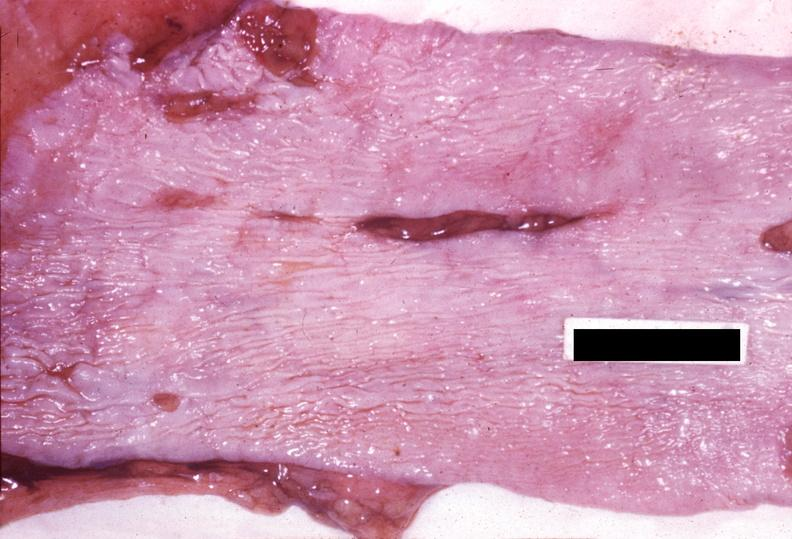s cardiovascular present?
Answer the question using a single word or phrase. No 